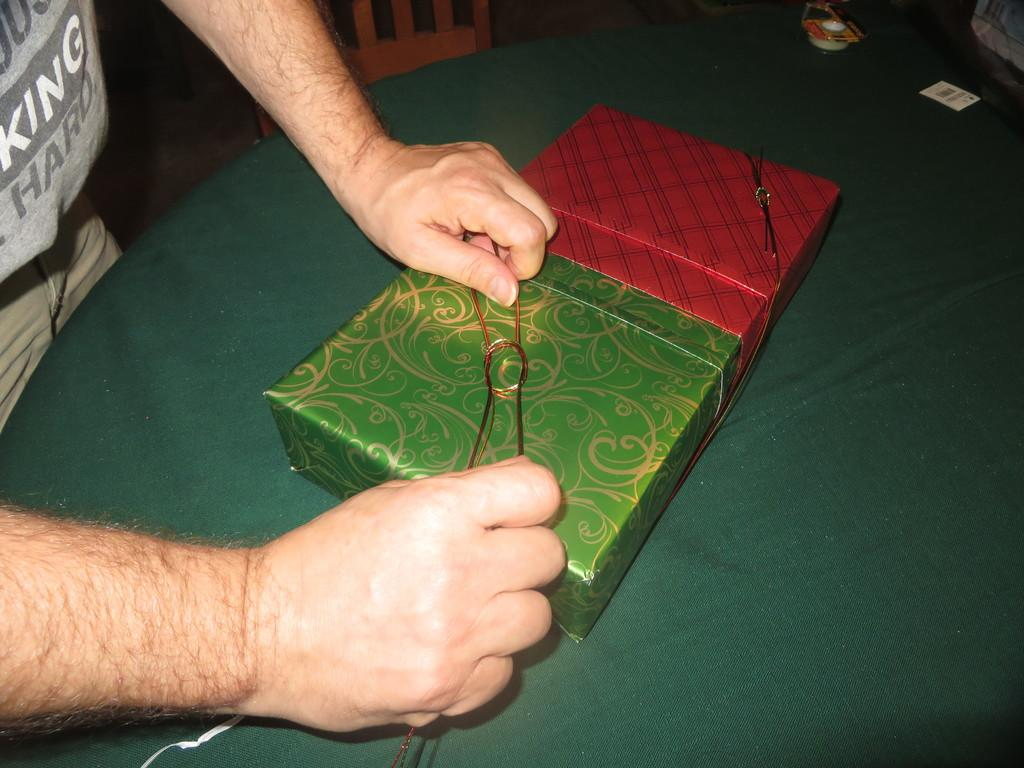What object is placed on the table in the image? There is a box on the table in the image. What activity is being performed by the person in the image? The hands of a person holding a thread can be seen in the image, suggesting that the person is engaged in some form of thread work or sewing. What type of chair is located beside the table? There is a wooden chair beside the table in the image. What type of card is being used by the person in the image? There is no card present in the image; the person's hands are holding a thread. What kind of camera can be seen in the image? There is no camera present in the image; the focus is on the box, the hands holding a thread, and the wooden chair. 